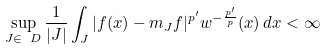Convert formula to latex. <formula><loc_0><loc_0><loc_500><loc_500>\sup _ { J \in \ D } \frac { 1 } { | J | } \int _ { J } | f ( x ) - m _ { J } f | ^ { p ^ { \prime } } w ^ { - \frac { p ^ { \prime } } { p } } ( x ) \, d x < \infty</formula> 